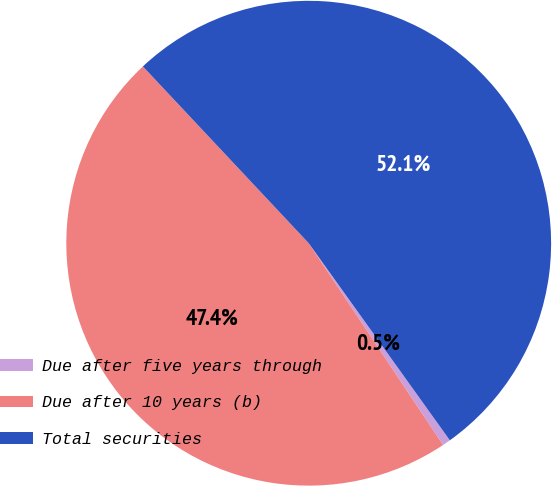<chart> <loc_0><loc_0><loc_500><loc_500><pie_chart><fcel>Due after five years through<fcel>Due after 10 years (b)<fcel>Total securities<nl><fcel>0.54%<fcel>47.36%<fcel>52.1%<nl></chart> 